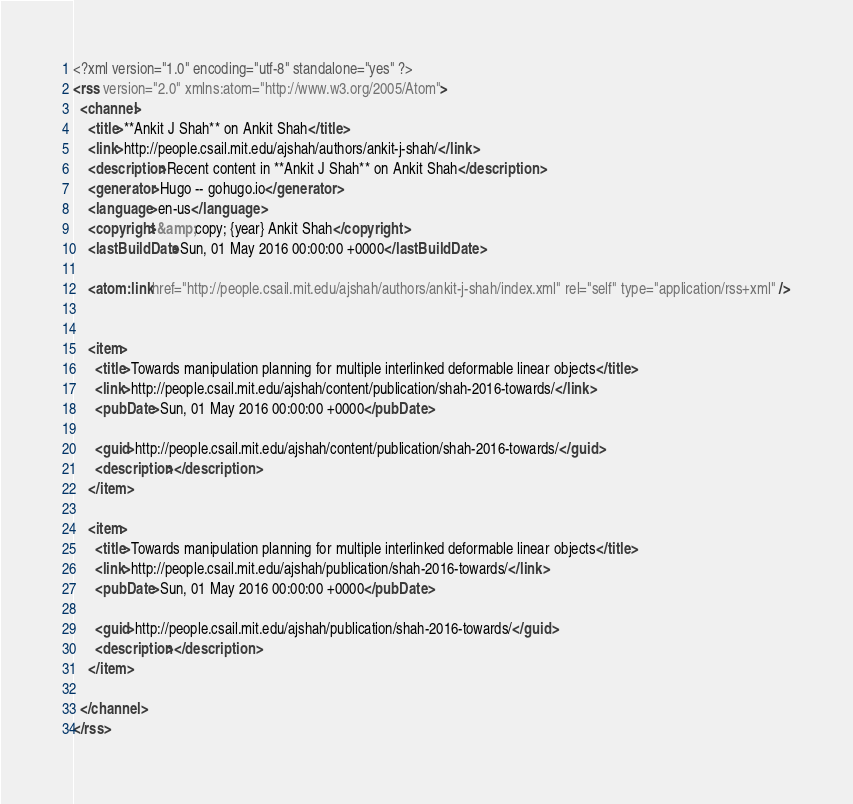<code> <loc_0><loc_0><loc_500><loc_500><_XML_><?xml version="1.0" encoding="utf-8" standalone="yes" ?>
<rss version="2.0" xmlns:atom="http://www.w3.org/2005/Atom">
  <channel>
    <title>**Ankit J Shah** on Ankit Shah</title>
    <link>http://people.csail.mit.edu/ajshah/authors/ankit-j-shah/</link>
    <description>Recent content in **Ankit J Shah** on Ankit Shah</description>
    <generator>Hugo -- gohugo.io</generator>
    <language>en-us</language>
    <copyright>&amp;copy; {year} Ankit Shah</copyright>
    <lastBuildDate>Sun, 01 May 2016 00:00:00 +0000</lastBuildDate>
    
	<atom:link href="http://people.csail.mit.edu/ajshah/authors/ankit-j-shah/index.xml" rel="self" type="application/rss+xml" />
    
    
    <item>
      <title>Towards manipulation planning for multiple interlinked deformable linear objects</title>
      <link>http://people.csail.mit.edu/ajshah/content/publication/shah-2016-towards/</link>
      <pubDate>Sun, 01 May 2016 00:00:00 +0000</pubDate>
      
      <guid>http://people.csail.mit.edu/ajshah/content/publication/shah-2016-towards/</guid>
      <description></description>
    </item>
    
    <item>
      <title>Towards manipulation planning for multiple interlinked deformable linear objects</title>
      <link>http://people.csail.mit.edu/ajshah/publication/shah-2016-towards/</link>
      <pubDate>Sun, 01 May 2016 00:00:00 +0000</pubDate>
      
      <guid>http://people.csail.mit.edu/ajshah/publication/shah-2016-towards/</guid>
      <description></description>
    </item>
    
  </channel>
</rss></code> 